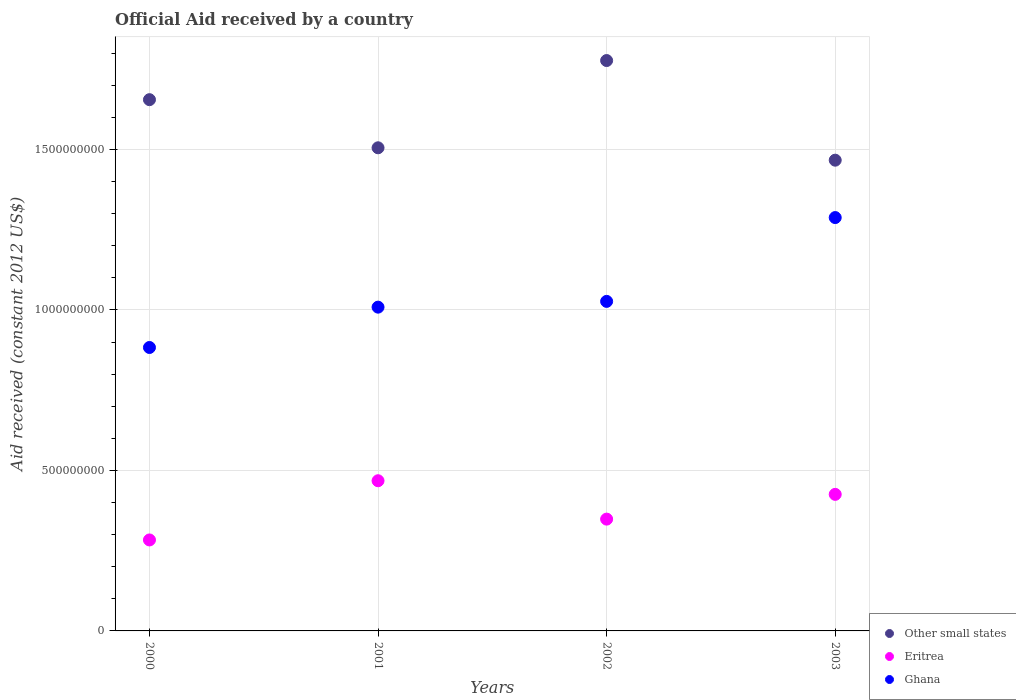How many different coloured dotlines are there?
Give a very brief answer. 3. Is the number of dotlines equal to the number of legend labels?
Your answer should be compact. Yes. What is the net official aid received in Other small states in 2000?
Offer a very short reply. 1.66e+09. Across all years, what is the maximum net official aid received in Eritrea?
Your answer should be compact. 4.68e+08. Across all years, what is the minimum net official aid received in Ghana?
Your response must be concise. 8.83e+08. In which year was the net official aid received in Eritrea minimum?
Ensure brevity in your answer.  2000. What is the total net official aid received in Ghana in the graph?
Your answer should be compact. 4.21e+09. What is the difference between the net official aid received in Ghana in 2000 and that in 2001?
Your response must be concise. -1.26e+08. What is the difference between the net official aid received in Other small states in 2002 and the net official aid received in Eritrea in 2003?
Make the answer very short. 1.35e+09. What is the average net official aid received in Eritrea per year?
Offer a terse response. 3.81e+08. In the year 2003, what is the difference between the net official aid received in Eritrea and net official aid received in Other small states?
Your answer should be compact. -1.04e+09. What is the ratio of the net official aid received in Eritrea in 2000 to that in 2001?
Ensure brevity in your answer.  0.61. What is the difference between the highest and the second highest net official aid received in Ghana?
Provide a short and direct response. 2.61e+08. What is the difference between the highest and the lowest net official aid received in Eritrea?
Your answer should be very brief. 1.84e+08. In how many years, is the net official aid received in Ghana greater than the average net official aid received in Ghana taken over all years?
Provide a succinct answer. 1. How many dotlines are there?
Offer a terse response. 3. What is the difference between two consecutive major ticks on the Y-axis?
Ensure brevity in your answer.  5.00e+08. How many legend labels are there?
Offer a terse response. 3. How are the legend labels stacked?
Give a very brief answer. Vertical. What is the title of the graph?
Ensure brevity in your answer.  Official Aid received by a country. What is the label or title of the Y-axis?
Make the answer very short. Aid received (constant 2012 US$). What is the Aid received (constant 2012 US$) in Other small states in 2000?
Offer a very short reply. 1.66e+09. What is the Aid received (constant 2012 US$) of Eritrea in 2000?
Your answer should be very brief. 2.83e+08. What is the Aid received (constant 2012 US$) of Ghana in 2000?
Your answer should be compact. 8.83e+08. What is the Aid received (constant 2012 US$) of Other small states in 2001?
Your answer should be compact. 1.51e+09. What is the Aid received (constant 2012 US$) in Eritrea in 2001?
Make the answer very short. 4.68e+08. What is the Aid received (constant 2012 US$) of Ghana in 2001?
Keep it short and to the point. 1.01e+09. What is the Aid received (constant 2012 US$) of Other small states in 2002?
Your answer should be very brief. 1.78e+09. What is the Aid received (constant 2012 US$) in Eritrea in 2002?
Provide a short and direct response. 3.48e+08. What is the Aid received (constant 2012 US$) of Ghana in 2002?
Ensure brevity in your answer.  1.03e+09. What is the Aid received (constant 2012 US$) in Other small states in 2003?
Offer a terse response. 1.47e+09. What is the Aid received (constant 2012 US$) of Eritrea in 2003?
Make the answer very short. 4.25e+08. What is the Aid received (constant 2012 US$) of Ghana in 2003?
Provide a short and direct response. 1.29e+09. Across all years, what is the maximum Aid received (constant 2012 US$) in Other small states?
Your answer should be compact. 1.78e+09. Across all years, what is the maximum Aid received (constant 2012 US$) of Eritrea?
Ensure brevity in your answer.  4.68e+08. Across all years, what is the maximum Aid received (constant 2012 US$) of Ghana?
Give a very brief answer. 1.29e+09. Across all years, what is the minimum Aid received (constant 2012 US$) in Other small states?
Provide a short and direct response. 1.47e+09. Across all years, what is the minimum Aid received (constant 2012 US$) in Eritrea?
Your response must be concise. 2.83e+08. Across all years, what is the minimum Aid received (constant 2012 US$) in Ghana?
Your answer should be compact. 8.83e+08. What is the total Aid received (constant 2012 US$) of Other small states in the graph?
Keep it short and to the point. 6.40e+09. What is the total Aid received (constant 2012 US$) of Eritrea in the graph?
Your answer should be compact. 1.52e+09. What is the total Aid received (constant 2012 US$) in Ghana in the graph?
Your answer should be compact. 4.21e+09. What is the difference between the Aid received (constant 2012 US$) of Other small states in 2000 and that in 2001?
Your answer should be compact. 1.50e+08. What is the difference between the Aid received (constant 2012 US$) in Eritrea in 2000 and that in 2001?
Give a very brief answer. -1.84e+08. What is the difference between the Aid received (constant 2012 US$) in Ghana in 2000 and that in 2001?
Give a very brief answer. -1.26e+08. What is the difference between the Aid received (constant 2012 US$) in Other small states in 2000 and that in 2002?
Offer a terse response. -1.22e+08. What is the difference between the Aid received (constant 2012 US$) in Eritrea in 2000 and that in 2002?
Provide a short and direct response. -6.49e+07. What is the difference between the Aid received (constant 2012 US$) in Ghana in 2000 and that in 2002?
Give a very brief answer. -1.44e+08. What is the difference between the Aid received (constant 2012 US$) in Other small states in 2000 and that in 2003?
Give a very brief answer. 1.89e+08. What is the difference between the Aid received (constant 2012 US$) of Eritrea in 2000 and that in 2003?
Offer a terse response. -1.42e+08. What is the difference between the Aid received (constant 2012 US$) of Ghana in 2000 and that in 2003?
Keep it short and to the point. -4.05e+08. What is the difference between the Aid received (constant 2012 US$) in Other small states in 2001 and that in 2002?
Offer a very short reply. -2.72e+08. What is the difference between the Aid received (constant 2012 US$) of Eritrea in 2001 and that in 2002?
Keep it short and to the point. 1.20e+08. What is the difference between the Aid received (constant 2012 US$) in Ghana in 2001 and that in 2002?
Your response must be concise. -1.80e+07. What is the difference between the Aid received (constant 2012 US$) in Other small states in 2001 and that in 2003?
Provide a short and direct response. 3.86e+07. What is the difference between the Aid received (constant 2012 US$) in Eritrea in 2001 and that in 2003?
Ensure brevity in your answer.  4.24e+07. What is the difference between the Aid received (constant 2012 US$) of Ghana in 2001 and that in 2003?
Your response must be concise. -2.79e+08. What is the difference between the Aid received (constant 2012 US$) of Other small states in 2002 and that in 2003?
Give a very brief answer. 3.10e+08. What is the difference between the Aid received (constant 2012 US$) in Eritrea in 2002 and that in 2003?
Your answer should be very brief. -7.71e+07. What is the difference between the Aid received (constant 2012 US$) of Ghana in 2002 and that in 2003?
Offer a very short reply. -2.61e+08. What is the difference between the Aid received (constant 2012 US$) in Other small states in 2000 and the Aid received (constant 2012 US$) in Eritrea in 2001?
Offer a very short reply. 1.19e+09. What is the difference between the Aid received (constant 2012 US$) in Other small states in 2000 and the Aid received (constant 2012 US$) in Ghana in 2001?
Provide a short and direct response. 6.46e+08. What is the difference between the Aid received (constant 2012 US$) of Eritrea in 2000 and the Aid received (constant 2012 US$) of Ghana in 2001?
Provide a short and direct response. -7.25e+08. What is the difference between the Aid received (constant 2012 US$) of Other small states in 2000 and the Aid received (constant 2012 US$) of Eritrea in 2002?
Give a very brief answer. 1.31e+09. What is the difference between the Aid received (constant 2012 US$) of Other small states in 2000 and the Aid received (constant 2012 US$) of Ghana in 2002?
Offer a very short reply. 6.28e+08. What is the difference between the Aid received (constant 2012 US$) of Eritrea in 2000 and the Aid received (constant 2012 US$) of Ghana in 2002?
Offer a terse response. -7.43e+08. What is the difference between the Aid received (constant 2012 US$) of Other small states in 2000 and the Aid received (constant 2012 US$) of Eritrea in 2003?
Provide a succinct answer. 1.23e+09. What is the difference between the Aid received (constant 2012 US$) of Other small states in 2000 and the Aid received (constant 2012 US$) of Ghana in 2003?
Keep it short and to the point. 3.67e+08. What is the difference between the Aid received (constant 2012 US$) of Eritrea in 2000 and the Aid received (constant 2012 US$) of Ghana in 2003?
Provide a short and direct response. -1.00e+09. What is the difference between the Aid received (constant 2012 US$) in Other small states in 2001 and the Aid received (constant 2012 US$) in Eritrea in 2002?
Offer a very short reply. 1.16e+09. What is the difference between the Aid received (constant 2012 US$) of Other small states in 2001 and the Aid received (constant 2012 US$) of Ghana in 2002?
Give a very brief answer. 4.78e+08. What is the difference between the Aid received (constant 2012 US$) in Eritrea in 2001 and the Aid received (constant 2012 US$) in Ghana in 2002?
Your answer should be compact. -5.59e+08. What is the difference between the Aid received (constant 2012 US$) of Other small states in 2001 and the Aid received (constant 2012 US$) of Eritrea in 2003?
Provide a succinct answer. 1.08e+09. What is the difference between the Aid received (constant 2012 US$) of Other small states in 2001 and the Aid received (constant 2012 US$) of Ghana in 2003?
Keep it short and to the point. 2.17e+08. What is the difference between the Aid received (constant 2012 US$) in Eritrea in 2001 and the Aid received (constant 2012 US$) in Ghana in 2003?
Provide a short and direct response. -8.20e+08. What is the difference between the Aid received (constant 2012 US$) of Other small states in 2002 and the Aid received (constant 2012 US$) of Eritrea in 2003?
Provide a succinct answer. 1.35e+09. What is the difference between the Aid received (constant 2012 US$) in Other small states in 2002 and the Aid received (constant 2012 US$) in Ghana in 2003?
Offer a very short reply. 4.89e+08. What is the difference between the Aid received (constant 2012 US$) in Eritrea in 2002 and the Aid received (constant 2012 US$) in Ghana in 2003?
Your response must be concise. -9.39e+08. What is the average Aid received (constant 2012 US$) of Other small states per year?
Ensure brevity in your answer.  1.60e+09. What is the average Aid received (constant 2012 US$) in Eritrea per year?
Provide a short and direct response. 3.81e+08. What is the average Aid received (constant 2012 US$) in Ghana per year?
Make the answer very short. 1.05e+09. In the year 2000, what is the difference between the Aid received (constant 2012 US$) of Other small states and Aid received (constant 2012 US$) of Eritrea?
Offer a very short reply. 1.37e+09. In the year 2000, what is the difference between the Aid received (constant 2012 US$) in Other small states and Aid received (constant 2012 US$) in Ghana?
Ensure brevity in your answer.  7.72e+08. In the year 2000, what is the difference between the Aid received (constant 2012 US$) of Eritrea and Aid received (constant 2012 US$) of Ghana?
Provide a succinct answer. -6.00e+08. In the year 2001, what is the difference between the Aid received (constant 2012 US$) of Other small states and Aid received (constant 2012 US$) of Eritrea?
Provide a short and direct response. 1.04e+09. In the year 2001, what is the difference between the Aid received (constant 2012 US$) in Other small states and Aid received (constant 2012 US$) in Ghana?
Offer a terse response. 4.96e+08. In the year 2001, what is the difference between the Aid received (constant 2012 US$) of Eritrea and Aid received (constant 2012 US$) of Ghana?
Your answer should be very brief. -5.41e+08. In the year 2002, what is the difference between the Aid received (constant 2012 US$) in Other small states and Aid received (constant 2012 US$) in Eritrea?
Provide a succinct answer. 1.43e+09. In the year 2002, what is the difference between the Aid received (constant 2012 US$) in Other small states and Aid received (constant 2012 US$) in Ghana?
Offer a terse response. 7.50e+08. In the year 2002, what is the difference between the Aid received (constant 2012 US$) of Eritrea and Aid received (constant 2012 US$) of Ghana?
Provide a short and direct response. -6.78e+08. In the year 2003, what is the difference between the Aid received (constant 2012 US$) in Other small states and Aid received (constant 2012 US$) in Eritrea?
Keep it short and to the point. 1.04e+09. In the year 2003, what is the difference between the Aid received (constant 2012 US$) of Other small states and Aid received (constant 2012 US$) of Ghana?
Your answer should be very brief. 1.79e+08. In the year 2003, what is the difference between the Aid received (constant 2012 US$) in Eritrea and Aid received (constant 2012 US$) in Ghana?
Provide a succinct answer. -8.62e+08. What is the ratio of the Aid received (constant 2012 US$) of Other small states in 2000 to that in 2001?
Your answer should be compact. 1.1. What is the ratio of the Aid received (constant 2012 US$) in Eritrea in 2000 to that in 2001?
Give a very brief answer. 0.61. What is the ratio of the Aid received (constant 2012 US$) in Ghana in 2000 to that in 2001?
Give a very brief answer. 0.88. What is the ratio of the Aid received (constant 2012 US$) in Other small states in 2000 to that in 2002?
Your answer should be very brief. 0.93. What is the ratio of the Aid received (constant 2012 US$) of Eritrea in 2000 to that in 2002?
Provide a short and direct response. 0.81. What is the ratio of the Aid received (constant 2012 US$) of Ghana in 2000 to that in 2002?
Give a very brief answer. 0.86. What is the ratio of the Aid received (constant 2012 US$) of Other small states in 2000 to that in 2003?
Ensure brevity in your answer.  1.13. What is the ratio of the Aid received (constant 2012 US$) in Eritrea in 2000 to that in 2003?
Make the answer very short. 0.67. What is the ratio of the Aid received (constant 2012 US$) of Ghana in 2000 to that in 2003?
Provide a succinct answer. 0.69. What is the ratio of the Aid received (constant 2012 US$) in Other small states in 2001 to that in 2002?
Offer a very short reply. 0.85. What is the ratio of the Aid received (constant 2012 US$) of Eritrea in 2001 to that in 2002?
Your answer should be very brief. 1.34. What is the ratio of the Aid received (constant 2012 US$) in Ghana in 2001 to that in 2002?
Ensure brevity in your answer.  0.98. What is the ratio of the Aid received (constant 2012 US$) in Other small states in 2001 to that in 2003?
Offer a terse response. 1.03. What is the ratio of the Aid received (constant 2012 US$) in Eritrea in 2001 to that in 2003?
Make the answer very short. 1.1. What is the ratio of the Aid received (constant 2012 US$) of Ghana in 2001 to that in 2003?
Your answer should be very brief. 0.78. What is the ratio of the Aid received (constant 2012 US$) in Other small states in 2002 to that in 2003?
Make the answer very short. 1.21. What is the ratio of the Aid received (constant 2012 US$) of Eritrea in 2002 to that in 2003?
Your response must be concise. 0.82. What is the ratio of the Aid received (constant 2012 US$) of Ghana in 2002 to that in 2003?
Your response must be concise. 0.8. What is the difference between the highest and the second highest Aid received (constant 2012 US$) in Other small states?
Make the answer very short. 1.22e+08. What is the difference between the highest and the second highest Aid received (constant 2012 US$) of Eritrea?
Offer a very short reply. 4.24e+07. What is the difference between the highest and the second highest Aid received (constant 2012 US$) in Ghana?
Your answer should be very brief. 2.61e+08. What is the difference between the highest and the lowest Aid received (constant 2012 US$) in Other small states?
Your answer should be very brief. 3.10e+08. What is the difference between the highest and the lowest Aid received (constant 2012 US$) of Eritrea?
Your response must be concise. 1.84e+08. What is the difference between the highest and the lowest Aid received (constant 2012 US$) of Ghana?
Provide a short and direct response. 4.05e+08. 